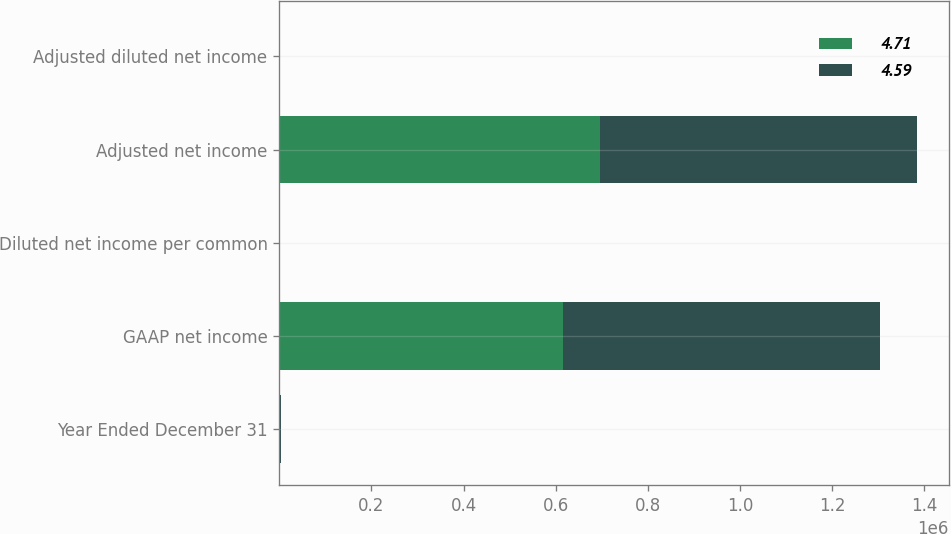<chart> <loc_0><loc_0><loc_500><loc_500><stacked_bar_chart><ecel><fcel>Year Ended December 31<fcel>GAAP net income<fcel>Diluted net income per common<fcel>Adjusted net income<fcel>Adjusted diluted net income<nl><fcel>4.71<fcel>2017<fcel>616757<fcel>4.18<fcel>695782<fcel>4.71<nl><fcel>4.59<fcel>2016<fcel>687240<fcel>4.59<fcel>687240<fcel>4.59<nl></chart> 